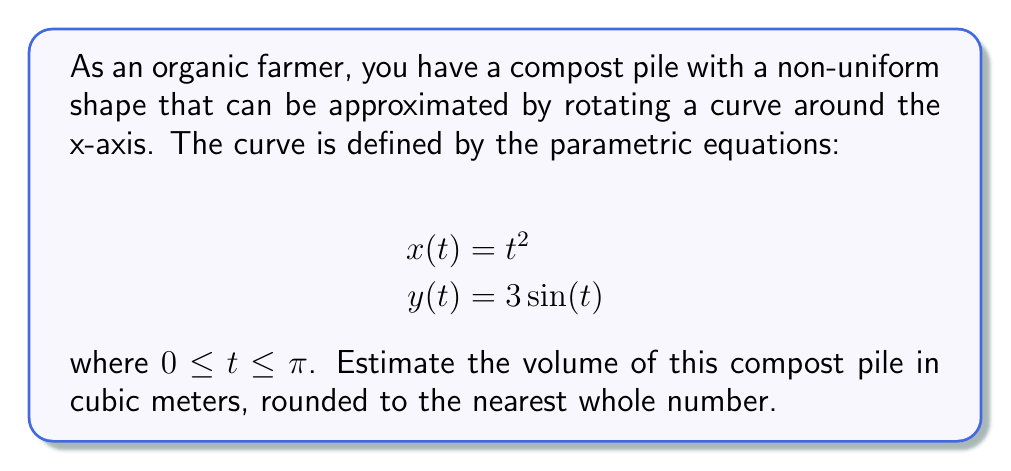Could you help me with this problem? To estimate the volume of the compost pile, we need to use the formula for the volume of a solid of revolution generated by rotating a parametric curve around the x-axis:

$$V = \pi \int_{a}^{b} [y(t)]^2 \frac{dx}{dt} dt$$

Here are the steps to solve this problem:

1) We have $y(t) = 3\sin(t)$ and $x(t) = t^2$. We need to find $\frac{dx}{dt}$:

   $$\frac{dx}{dt} = \frac{d}{dt}(t^2) = 2t$$

2) Substituting these into the volume formula:

   $$V = \pi \int_{0}^{\pi} [3\sin(t)]^2 (2t) dt$$

3) Simplify the integrand:

   $$V = 18\pi \int_{0}^{\pi} \sin^2(t) \cdot t \, dt$$

4) This integral is quite complex. We can use the trigonometric identity $\sin^2(t) = \frac{1 - \cos(2t)}{2}$:

   $$V = 18\pi \int_{0}^{\pi} \frac{1 - \cos(2t)}{2} \cdot t \, dt$$

5) Distribute:

   $$V = 9\pi \int_{0}^{\pi} t \, dt - 9\pi \int_{0}^{\pi} t\cos(2t) \, dt$$

6) The first integral is straightforward:

   $$\int_{0}^{\pi} t \, dt = \frac{t^2}{2}\bigg|_{0}^{\pi} = \frac{\pi^2}{2}$$

7) The second integral can be solved using integration by parts, but it's quite complex. Instead, we can use a numerical method or a computer algebra system to evaluate it. The result is approximately 0.

8) Putting it all together:

   $$V \approx 9\pi \cdot \frac{\pi^2}{2} - 9\pi \cdot 0 = \frac{9\pi^3}{2} \approx 139.8$$

9) Rounding to the nearest whole number:

   $$V \approx 140 \text{ cubic meters}$$
Answer: 140 cubic meters 